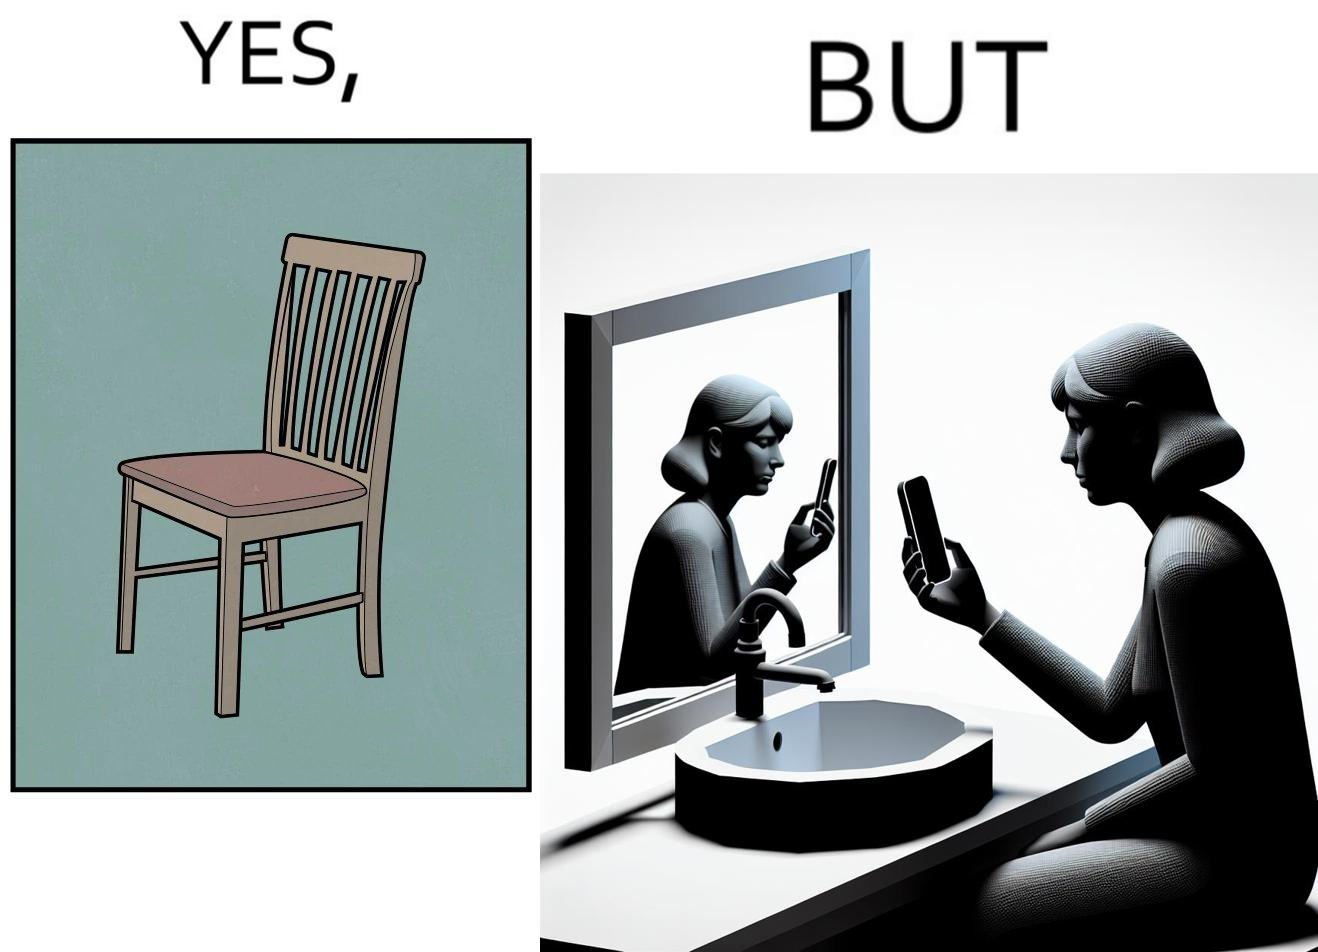Describe the contrast between the left and right parts of this image. In the left part of the image: a chair. In the right part of the image: a woman sitting by the sink taking a selfie using a mirror. 